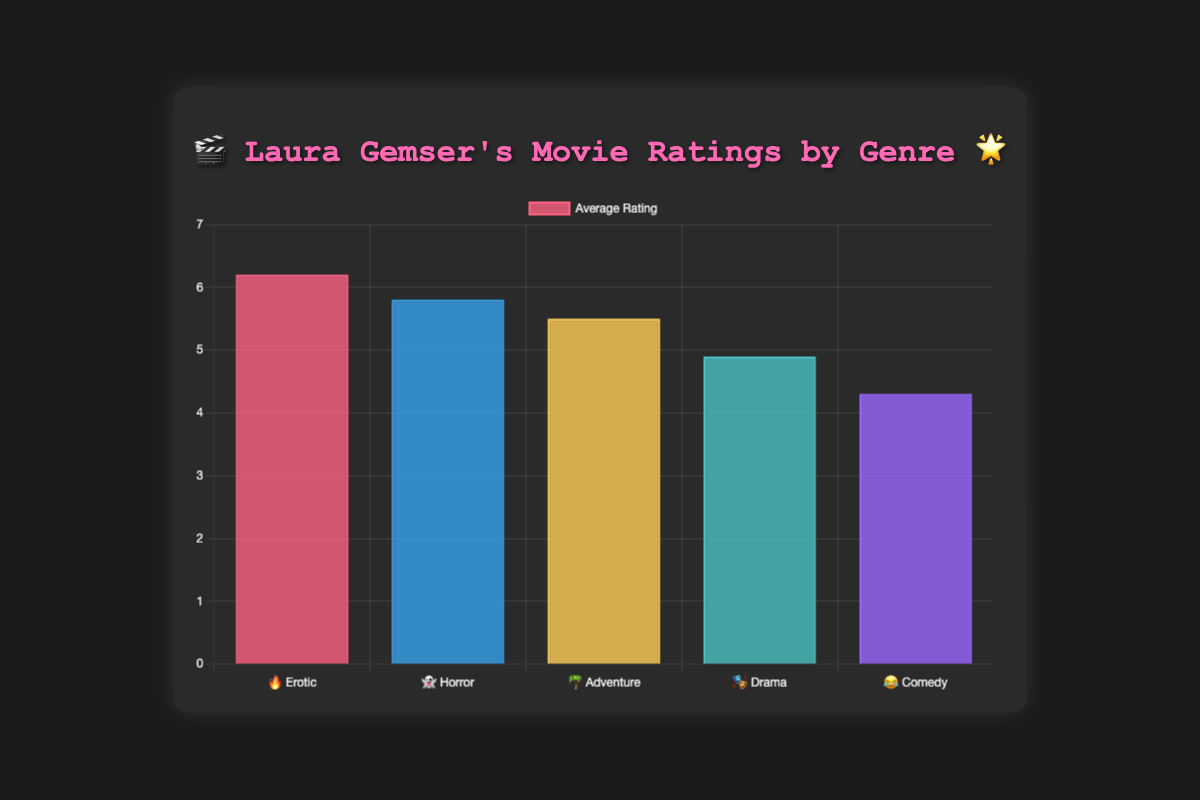What is the highest rated genre? The highest-rated genre can be identified by looking at the tallest bar in the chart. The "🔥 Erotic" bar is the tallest, corresponding to an average rating of 6.2.
Answer: Erotic Which genre has the lowest average rating? To find the genre with the lowest rating, look for the shortest bar in the chart, which is the "😂 Comedy" bar with an average rating of 4.3.
Answer: Comedy How much higher is the rating for "Erotic" compared to "Comedy"? Find the ratings for both genres: "Erotic" is 6.2 and "Comedy" is 4.3. The difference is 6.2 - 4.3 = 1.9.
Answer: 1.9 Which genre's average rating is closest to 5.5? Look at the bars and their associated values. The rating closest to 5.5 is the "👻 Horror" genre with a rating of 5.5.
Answer: Adventure What is the combined rating of the "Drama" and "Comedy" genres? Add the ratings of both genres: "Drama" is 4.9 and "Comedy" is 4.3. The combined rating is 4.9 + 4.3 = 9.2.
Answer: 9.2 Which genre shows the second highest rating? Identify the second tallest bar, which is the "👻 Horror" genre with a rating of 5.8.
Answer: Horror What is the difference in ratings between the genres "Horror" and "Drama"? Subtract the rating of "Drama" (4.9) from "Horror" (5.8): 5.8 - 4.9 = 0.9.
Answer: 0.9 How many genres have an average rating above 5.5? Check all genres with bars taller than the 5.5 mark: "Erotic" (6.2), "Horror" (5.8). There are 2 such genres.
Answer: 2 What movie accompanies the highest-rated genre? The top movie for the "🔥 Erotic" genre, which has the highest rating, is "Black Emanuelle."
Answer: Black Emanuelle Is the rating of "Adventure" higher or lower than the overall average rating of all genres? Calculate the overall average rating: (6.2 + 5.8 + 5.5 + 4.9 + 4.3) / 5 = 5.34. The "Adventure" rating is 5.5, which is higher than the overall average.
Answer: Higher 